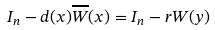<formula> <loc_0><loc_0><loc_500><loc_500>I _ { n } - d ( x ) \overline { W } ( x ) = I _ { n } - r W ( y )</formula> 